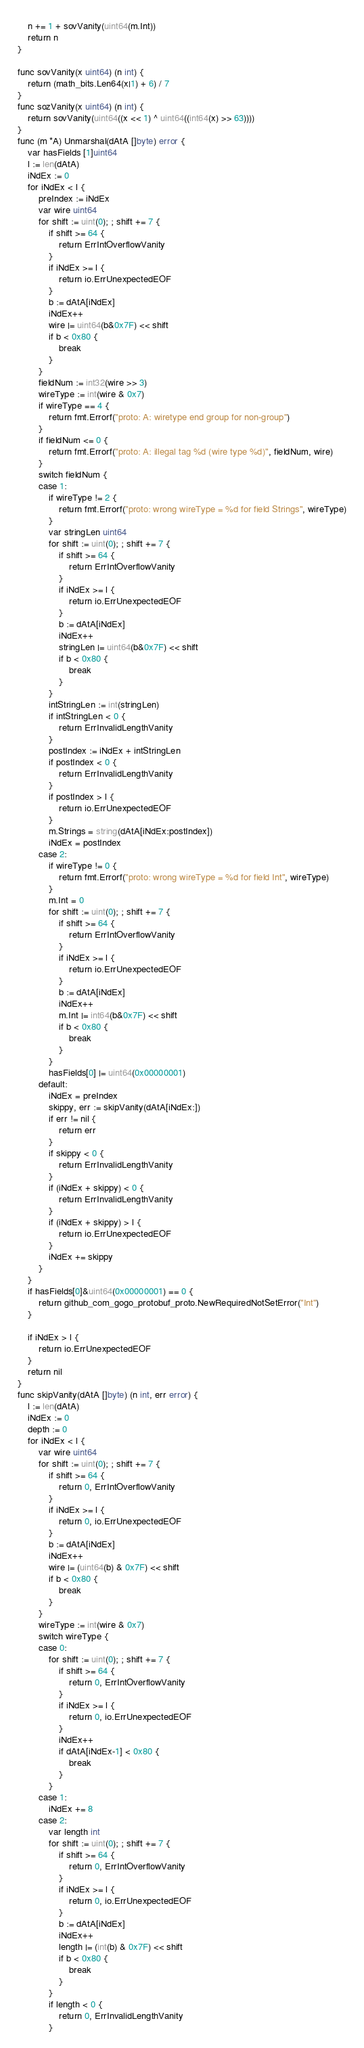Convert code to text. <code><loc_0><loc_0><loc_500><loc_500><_Go_>	n += 1 + sovVanity(uint64(m.Int))
	return n
}

func sovVanity(x uint64) (n int) {
	return (math_bits.Len64(x|1) + 6) / 7
}
func sozVanity(x uint64) (n int) {
	return sovVanity(uint64((x << 1) ^ uint64((int64(x) >> 63))))
}
func (m *A) Unmarshal(dAtA []byte) error {
	var hasFields [1]uint64
	l := len(dAtA)
	iNdEx := 0
	for iNdEx < l {
		preIndex := iNdEx
		var wire uint64
		for shift := uint(0); ; shift += 7 {
			if shift >= 64 {
				return ErrIntOverflowVanity
			}
			if iNdEx >= l {
				return io.ErrUnexpectedEOF
			}
			b := dAtA[iNdEx]
			iNdEx++
			wire |= uint64(b&0x7F) << shift
			if b < 0x80 {
				break
			}
		}
		fieldNum := int32(wire >> 3)
		wireType := int(wire & 0x7)
		if wireType == 4 {
			return fmt.Errorf("proto: A: wiretype end group for non-group")
		}
		if fieldNum <= 0 {
			return fmt.Errorf("proto: A: illegal tag %d (wire type %d)", fieldNum, wire)
		}
		switch fieldNum {
		case 1:
			if wireType != 2 {
				return fmt.Errorf("proto: wrong wireType = %d for field Strings", wireType)
			}
			var stringLen uint64
			for shift := uint(0); ; shift += 7 {
				if shift >= 64 {
					return ErrIntOverflowVanity
				}
				if iNdEx >= l {
					return io.ErrUnexpectedEOF
				}
				b := dAtA[iNdEx]
				iNdEx++
				stringLen |= uint64(b&0x7F) << shift
				if b < 0x80 {
					break
				}
			}
			intStringLen := int(stringLen)
			if intStringLen < 0 {
				return ErrInvalidLengthVanity
			}
			postIndex := iNdEx + intStringLen
			if postIndex < 0 {
				return ErrInvalidLengthVanity
			}
			if postIndex > l {
				return io.ErrUnexpectedEOF
			}
			m.Strings = string(dAtA[iNdEx:postIndex])
			iNdEx = postIndex
		case 2:
			if wireType != 0 {
				return fmt.Errorf("proto: wrong wireType = %d for field Int", wireType)
			}
			m.Int = 0
			for shift := uint(0); ; shift += 7 {
				if shift >= 64 {
					return ErrIntOverflowVanity
				}
				if iNdEx >= l {
					return io.ErrUnexpectedEOF
				}
				b := dAtA[iNdEx]
				iNdEx++
				m.Int |= int64(b&0x7F) << shift
				if b < 0x80 {
					break
				}
			}
			hasFields[0] |= uint64(0x00000001)
		default:
			iNdEx = preIndex
			skippy, err := skipVanity(dAtA[iNdEx:])
			if err != nil {
				return err
			}
			if skippy < 0 {
				return ErrInvalidLengthVanity
			}
			if (iNdEx + skippy) < 0 {
				return ErrInvalidLengthVanity
			}
			if (iNdEx + skippy) > l {
				return io.ErrUnexpectedEOF
			}
			iNdEx += skippy
		}
	}
	if hasFields[0]&uint64(0x00000001) == 0 {
		return github_com_gogo_protobuf_proto.NewRequiredNotSetError("Int")
	}

	if iNdEx > l {
		return io.ErrUnexpectedEOF
	}
	return nil
}
func skipVanity(dAtA []byte) (n int, err error) {
	l := len(dAtA)
	iNdEx := 0
	depth := 0
	for iNdEx < l {
		var wire uint64
		for shift := uint(0); ; shift += 7 {
			if shift >= 64 {
				return 0, ErrIntOverflowVanity
			}
			if iNdEx >= l {
				return 0, io.ErrUnexpectedEOF
			}
			b := dAtA[iNdEx]
			iNdEx++
			wire |= (uint64(b) & 0x7F) << shift
			if b < 0x80 {
				break
			}
		}
		wireType := int(wire & 0x7)
		switch wireType {
		case 0:
			for shift := uint(0); ; shift += 7 {
				if shift >= 64 {
					return 0, ErrIntOverflowVanity
				}
				if iNdEx >= l {
					return 0, io.ErrUnexpectedEOF
				}
				iNdEx++
				if dAtA[iNdEx-1] < 0x80 {
					break
				}
			}
		case 1:
			iNdEx += 8
		case 2:
			var length int
			for shift := uint(0); ; shift += 7 {
				if shift >= 64 {
					return 0, ErrIntOverflowVanity
				}
				if iNdEx >= l {
					return 0, io.ErrUnexpectedEOF
				}
				b := dAtA[iNdEx]
				iNdEx++
				length |= (int(b) & 0x7F) << shift
				if b < 0x80 {
					break
				}
			}
			if length < 0 {
				return 0, ErrInvalidLengthVanity
			}</code> 